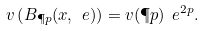Convert formula to latex. <formula><loc_0><loc_0><loc_500><loc_500>v \left ( B _ { \P p } ( x , \ e ) \right ) = v ( \P p ) \ e ^ { 2 p } .</formula> 